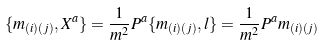<formula> <loc_0><loc_0><loc_500><loc_500>\{ m _ { ( i ) ( j ) } , X ^ { a } \} = \frac { 1 } { m ^ { 2 } } P ^ { a } \{ m _ { ( i ) ( j ) } , l \} = \frac { 1 } { m ^ { 2 } } P ^ { a } m _ { ( i ) ( j ) }</formula> 